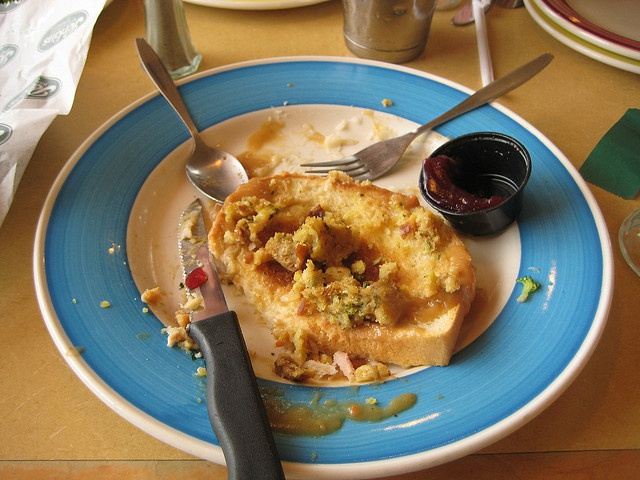Describe the objects in this image and their specific colors. I can see sandwich in black, red, tan, orange, and maroon tones, dining table in black, tan, olive, and maroon tones, knife in black, gray, and tan tones, cup in black, maroon, gray, and darkgray tones, and cup in black, maroon, olive, and tan tones in this image. 